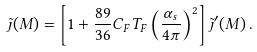<formula> <loc_0><loc_0><loc_500><loc_500>\tilde { \jmath } ( M ) = \left [ 1 + \frac { 8 9 } { 3 6 } C _ { F } T _ { F } \left ( \frac { \alpha _ { s } } { 4 \pi } \right ) ^ { 2 } \right ] \tilde { \jmath } ^ { \prime } ( M ) \, .</formula> 